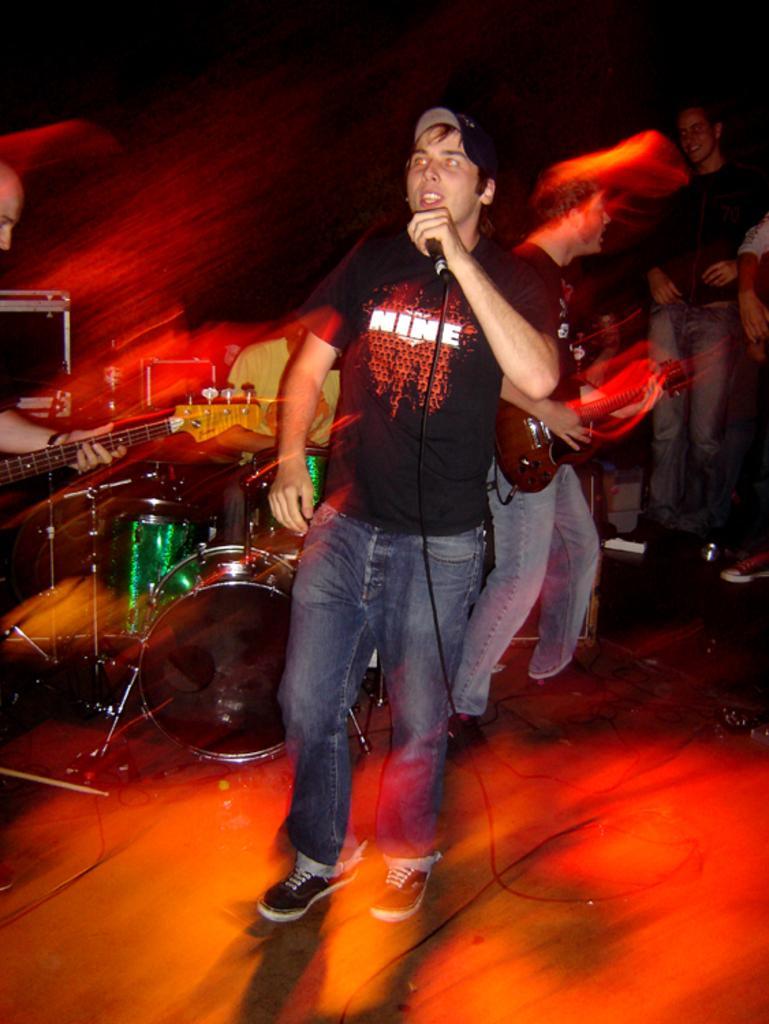Describe this image in one or two sentences. The person wearing black shirt is standing and singing in front of a mic and there are group of people playing music behind him. 